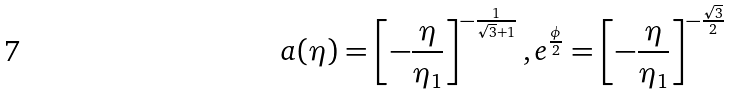Convert formula to latex. <formula><loc_0><loc_0><loc_500><loc_500>a ( \eta ) = \left [ - \frac { \eta } { \eta _ { 1 } } \right ] ^ { - \frac { 1 } { \sqrt { 3 } + 1 } } , e ^ { \frac { \phi } { 2 } } = \left [ - \frac { \eta } { \eta _ { 1 } } \right ] ^ { - \frac { \sqrt { 3 } } { 2 } }</formula> 